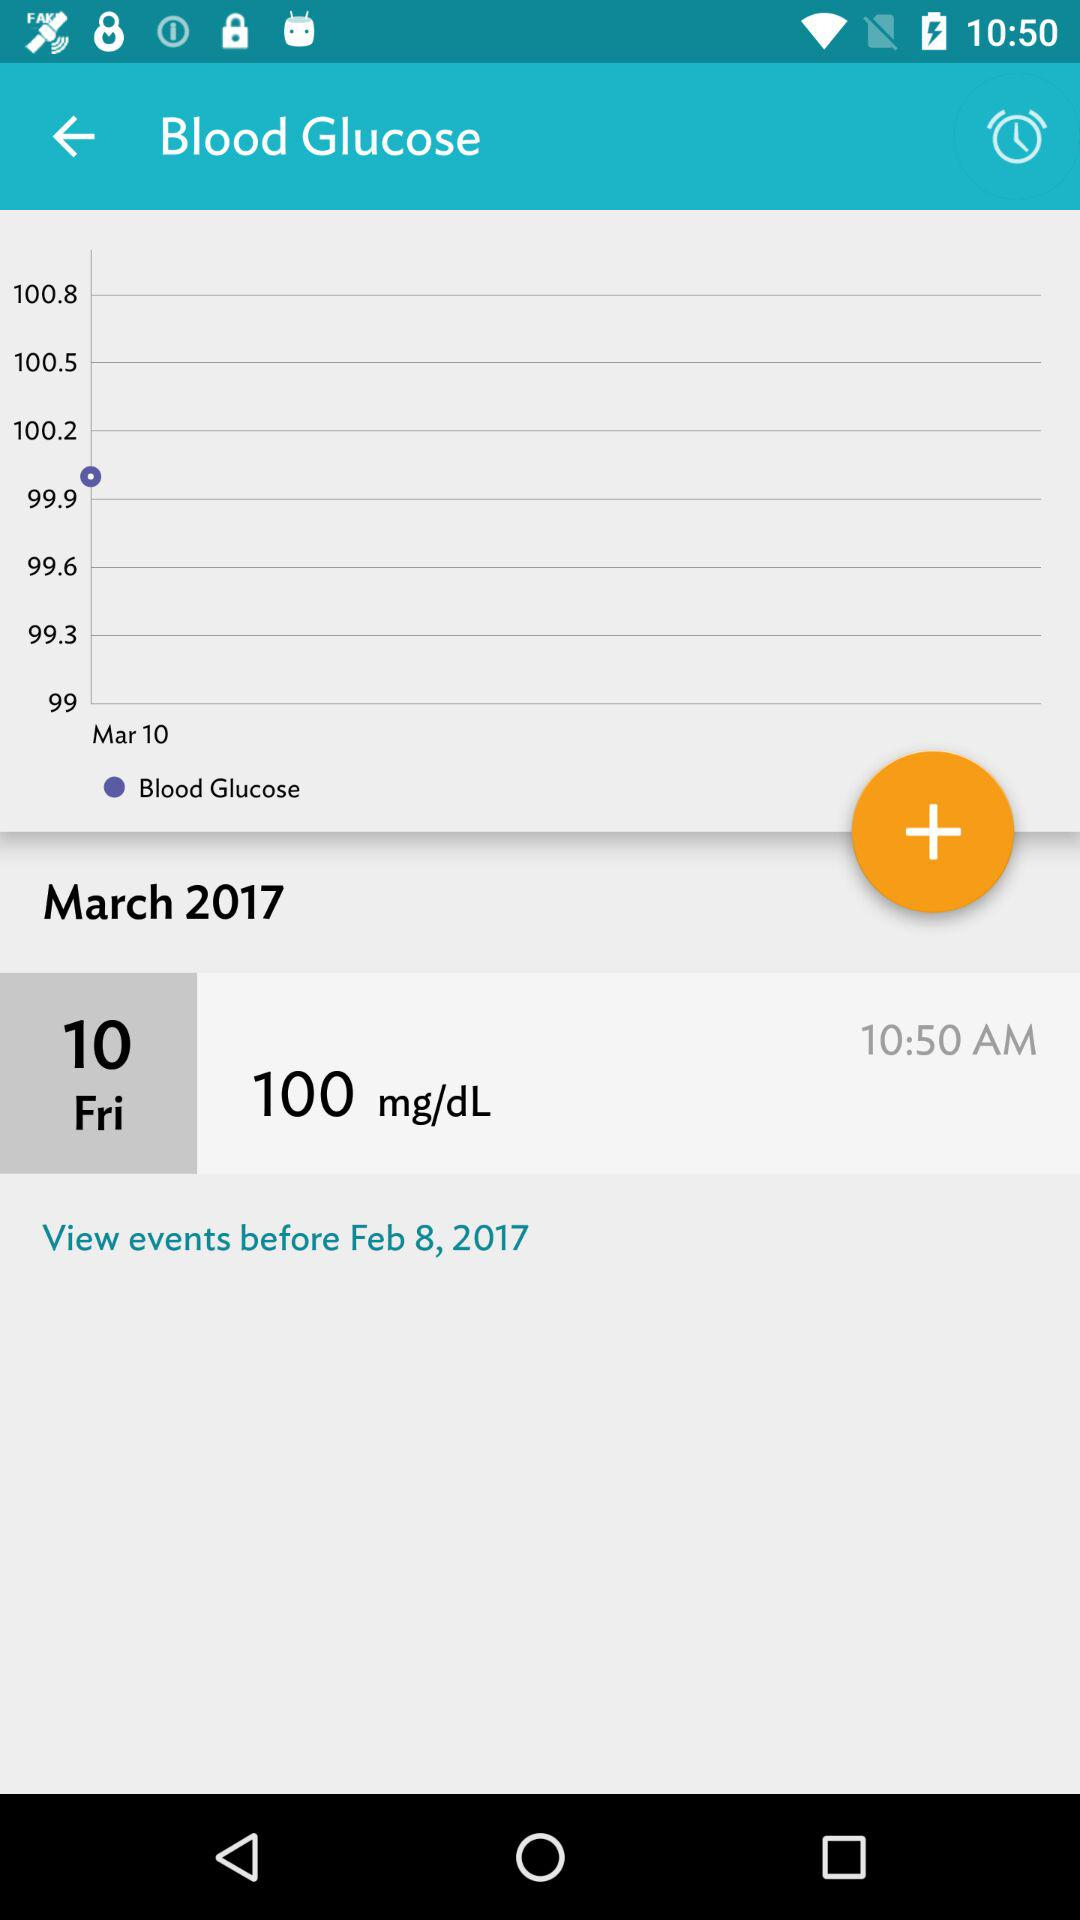How many blood glucose measurements are shown on the timeline?
Answer the question using a single word or phrase. 7 